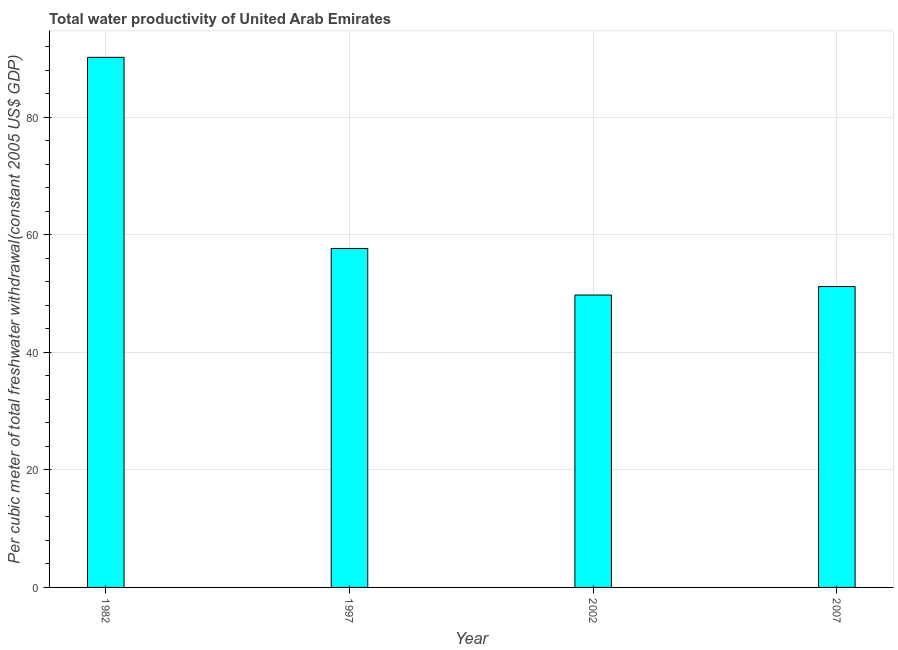Does the graph contain grids?
Make the answer very short. Yes. What is the title of the graph?
Provide a succinct answer. Total water productivity of United Arab Emirates. What is the label or title of the X-axis?
Make the answer very short. Year. What is the label or title of the Y-axis?
Your answer should be very brief. Per cubic meter of total freshwater withdrawal(constant 2005 US$ GDP). What is the total water productivity in 1982?
Provide a succinct answer. 90.21. Across all years, what is the maximum total water productivity?
Give a very brief answer. 90.21. Across all years, what is the minimum total water productivity?
Ensure brevity in your answer.  49.76. In which year was the total water productivity maximum?
Your answer should be compact. 1982. In which year was the total water productivity minimum?
Your response must be concise. 2002. What is the sum of the total water productivity?
Give a very brief answer. 248.86. What is the difference between the total water productivity in 1982 and 1997?
Provide a short and direct response. 32.52. What is the average total water productivity per year?
Your answer should be very brief. 62.21. What is the median total water productivity?
Your answer should be compact. 54.44. Do a majority of the years between 1982 and 1997 (inclusive) have total water productivity greater than 24 US$?
Your response must be concise. Yes. What is the ratio of the total water productivity in 1982 to that in 2007?
Keep it short and to the point. 1.76. What is the difference between the highest and the second highest total water productivity?
Keep it short and to the point. 32.52. What is the difference between the highest and the lowest total water productivity?
Offer a very short reply. 40.45. Are the values on the major ticks of Y-axis written in scientific E-notation?
Make the answer very short. No. What is the Per cubic meter of total freshwater withdrawal(constant 2005 US$ GDP) of 1982?
Your answer should be very brief. 90.21. What is the Per cubic meter of total freshwater withdrawal(constant 2005 US$ GDP) of 1997?
Offer a terse response. 57.69. What is the Per cubic meter of total freshwater withdrawal(constant 2005 US$ GDP) in 2002?
Your response must be concise. 49.76. What is the Per cubic meter of total freshwater withdrawal(constant 2005 US$ GDP) in 2007?
Provide a succinct answer. 51.2. What is the difference between the Per cubic meter of total freshwater withdrawal(constant 2005 US$ GDP) in 1982 and 1997?
Give a very brief answer. 32.52. What is the difference between the Per cubic meter of total freshwater withdrawal(constant 2005 US$ GDP) in 1982 and 2002?
Offer a terse response. 40.45. What is the difference between the Per cubic meter of total freshwater withdrawal(constant 2005 US$ GDP) in 1982 and 2007?
Provide a succinct answer. 39.01. What is the difference between the Per cubic meter of total freshwater withdrawal(constant 2005 US$ GDP) in 1997 and 2002?
Your answer should be compact. 7.93. What is the difference between the Per cubic meter of total freshwater withdrawal(constant 2005 US$ GDP) in 1997 and 2007?
Your answer should be very brief. 6.49. What is the difference between the Per cubic meter of total freshwater withdrawal(constant 2005 US$ GDP) in 2002 and 2007?
Make the answer very short. -1.44. What is the ratio of the Per cubic meter of total freshwater withdrawal(constant 2005 US$ GDP) in 1982 to that in 1997?
Your response must be concise. 1.56. What is the ratio of the Per cubic meter of total freshwater withdrawal(constant 2005 US$ GDP) in 1982 to that in 2002?
Keep it short and to the point. 1.81. What is the ratio of the Per cubic meter of total freshwater withdrawal(constant 2005 US$ GDP) in 1982 to that in 2007?
Your answer should be very brief. 1.76. What is the ratio of the Per cubic meter of total freshwater withdrawal(constant 2005 US$ GDP) in 1997 to that in 2002?
Keep it short and to the point. 1.16. What is the ratio of the Per cubic meter of total freshwater withdrawal(constant 2005 US$ GDP) in 1997 to that in 2007?
Your response must be concise. 1.13. What is the ratio of the Per cubic meter of total freshwater withdrawal(constant 2005 US$ GDP) in 2002 to that in 2007?
Your response must be concise. 0.97. 